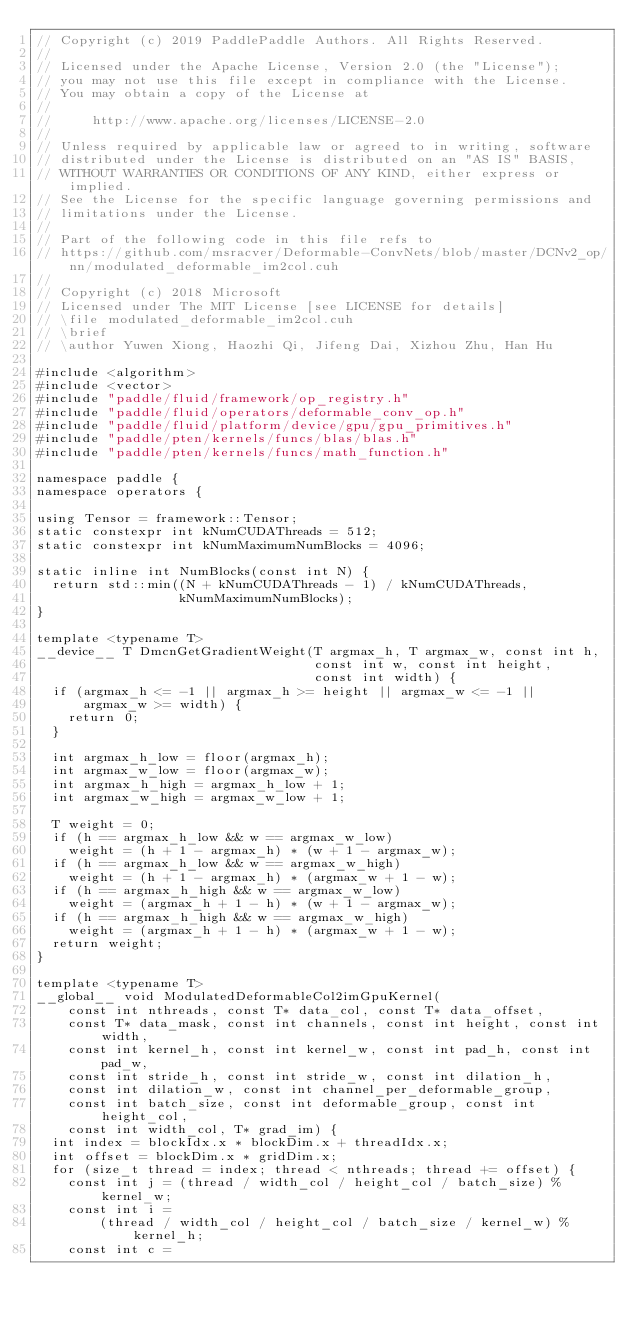<code> <loc_0><loc_0><loc_500><loc_500><_Cuda_>// Copyright (c) 2019 PaddlePaddle Authors. All Rights Reserved.
//
// Licensed under the Apache License, Version 2.0 (the "License");
// you may not use this file except in compliance with the License.
// You may obtain a copy of the License at
//
//     http://www.apache.org/licenses/LICENSE-2.0
//
// Unless required by applicable law or agreed to in writing, software
// distributed under the License is distributed on an "AS IS" BASIS,
// WITHOUT WARRANTIES OR CONDITIONS OF ANY KIND, either express or implied.
// See the License for the specific language governing permissions and
// limitations under the License.
//
// Part of the following code in this file refs to
// https://github.com/msracver/Deformable-ConvNets/blob/master/DCNv2_op/nn/modulated_deformable_im2col.cuh
//
// Copyright (c) 2018 Microsoft
// Licensed under The MIT License [see LICENSE for details]
// \file modulated_deformable_im2col.cuh
// \brief
// \author Yuwen Xiong, Haozhi Qi, Jifeng Dai, Xizhou Zhu, Han Hu

#include <algorithm>
#include <vector>
#include "paddle/fluid/framework/op_registry.h"
#include "paddle/fluid/operators/deformable_conv_op.h"
#include "paddle/fluid/platform/device/gpu/gpu_primitives.h"
#include "paddle/pten/kernels/funcs/blas/blas.h"
#include "paddle/pten/kernels/funcs/math_function.h"

namespace paddle {
namespace operators {

using Tensor = framework::Tensor;
static constexpr int kNumCUDAThreads = 512;
static constexpr int kNumMaximumNumBlocks = 4096;

static inline int NumBlocks(const int N) {
  return std::min((N + kNumCUDAThreads - 1) / kNumCUDAThreads,
                  kNumMaximumNumBlocks);
}

template <typename T>
__device__ T DmcnGetGradientWeight(T argmax_h, T argmax_w, const int h,
                                   const int w, const int height,
                                   const int width) {
  if (argmax_h <= -1 || argmax_h >= height || argmax_w <= -1 ||
      argmax_w >= width) {
    return 0;
  }

  int argmax_h_low = floor(argmax_h);
  int argmax_w_low = floor(argmax_w);
  int argmax_h_high = argmax_h_low + 1;
  int argmax_w_high = argmax_w_low + 1;

  T weight = 0;
  if (h == argmax_h_low && w == argmax_w_low)
    weight = (h + 1 - argmax_h) * (w + 1 - argmax_w);
  if (h == argmax_h_low && w == argmax_w_high)
    weight = (h + 1 - argmax_h) * (argmax_w + 1 - w);
  if (h == argmax_h_high && w == argmax_w_low)
    weight = (argmax_h + 1 - h) * (w + 1 - argmax_w);
  if (h == argmax_h_high && w == argmax_w_high)
    weight = (argmax_h + 1 - h) * (argmax_w + 1 - w);
  return weight;
}

template <typename T>
__global__ void ModulatedDeformableCol2imGpuKernel(
    const int nthreads, const T* data_col, const T* data_offset,
    const T* data_mask, const int channels, const int height, const int width,
    const int kernel_h, const int kernel_w, const int pad_h, const int pad_w,
    const int stride_h, const int stride_w, const int dilation_h,
    const int dilation_w, const int channel_per_deformable_group,
    const int batch_size, const int deformable_group, const int height_col,
    const int width_col, T* grad_im) {
  int index = blockIdx.x * blockDim.x + threadIdx.x;
  int offset = blockDim.x * gridDim.x;
  for (size_t thread = index; thread < nthreads; thread += offset) {
    const int j = (thread / width_col / height_col / batch_size) % kernel_w;
    const int i =
        (thread / width_col / height_col / batch_size / kernel_w) % kernel_h;
    const int c =</code> 